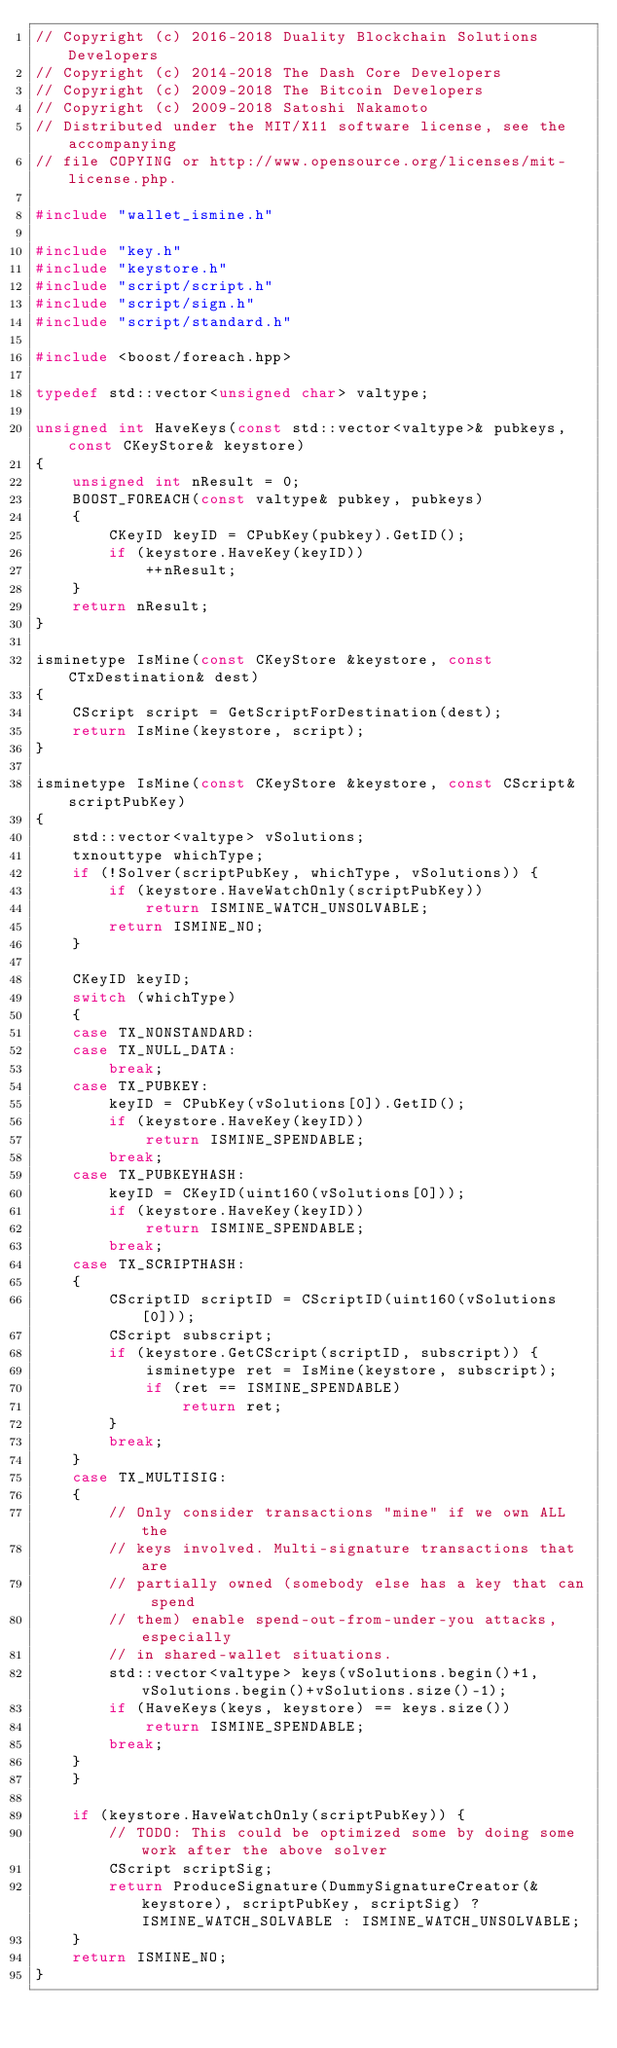<code> <loc_0><loc_0><loc_500><loc_500><_C++_>// Copyright (c) 2016-2018 Duality Blockchain Solutions Developers
// Copyright (c) 2014-2018 The Dash Core Developers
// Copyright (c) 2009-2018 The Bitcoin Developers
// Copyright (c) 2009-2018 Satoshi Nakamoto
// Distributed under the MIT/X11 software license, see the accompanying
// file COPYING or http://www.opensource.org/licenses/mit-license.php.

#include "wallet_ismine.h"

#include "key.h"
#include "keystore.h"
#include "script/script.h"
#include "script/sign.h"
#include "script/standard.h"

#include <boost/foreach.hpp>

typedef std::vector<unsigned char> valtype;

unsigned int HaveKeys(const std::vector<valtype>& pubkeys, const CKeyStore& keystore)
{
    unsigned int nResult = 0;
    BOOST_FOREACH(const valtype& pubkey, pubkeys)
    {
        CKeyID keyID = CPubKey(pubkey).GetID();
        if (keystore.HaveKey(keyID))
            ++nResult;
    }
    return nResult;
}

isminetype IsMine(const CKeyStore &keystore, const CTxDestination& dest)
{
    CScript script = GetScriptForDestination(dest);
    return IsMine(keystore, script);
}

isminetype IsMine(const CKeyStore &keystore, const CScript& scriptPubKey)
{
    std::vector<valtype> vSolutions;
    txnouttype whichType;
    if (!Solver(scriptPubKey, whichType, vSolutions)) {
        if (keystore.HaveWatchOnly(scriptPubKey))
            return ISMINE_WATCH_UNSOLVABLE;
        return ISMINE_NO;
    }

    CKeyID keyID;
    switch (whichType)
    {
    case TX_NONSTANDARD:
    case TX_NULL_DATA:
        break;
    case TX_PUBKEY:
        keyID = CPubKey(vSolutions[0]).GetID();
        if (keystore.HaveKey(keyID))
            return ISMINE_SPENDABLE;
        break;
    case TX_PUBKEYHASH:
        keyID = CKeyID(uint160(vSolutions[0]));
        if (keystore.HaveKey(keyID))
            return ISMINE_SPENDABLE;
        break;
    case TX_SCRIPTHASH:
    {
        CScriptID scriptID = CScriptID(uint160(vSolutions[0]));
        CScript subscript;
        if (keystore.GetCScript(scriptID, subscript)) {
            isminetype ret = IsMine(keystore, subscript);
            if (ret == ISMINE_SPENDABLE)
                return ret;
        }
        break;
    }
    case TX_MULTISIG:
    {
        // Only consider transactions "mine" if we own ALL the
        // keys involved. Multi-signature transactions that are
        // partially owned (somebody else has a key that can spend
        // them) enable spend-out-from-under-you attacks, especially
        // in shared-wallet situations.
        std::vector<valtype> keys(vSolutions.begin()+1, vSolutions.begin()+vSolutions.size()-1);
        if (HaveKeys(keys, keystore) == keys.size())
            return ISMINE_SPENDABLE;
        break;
    }
    }

    if (keystore.HaveWatchOnly(scriptPubKey)) {
        // TODO: This could be optimized some by doing some work after the above solver
        CScript scriptSig;
        return ProduceSignature(DummySignatureCreator(&keystore), scriptPubKey, scriptSig) ? ISMINE_WATCH_SOLVABLE : ISMINE_WATCH_UNSOLVABLE;
    }
    return ISMINE_NO;
}
</code> 